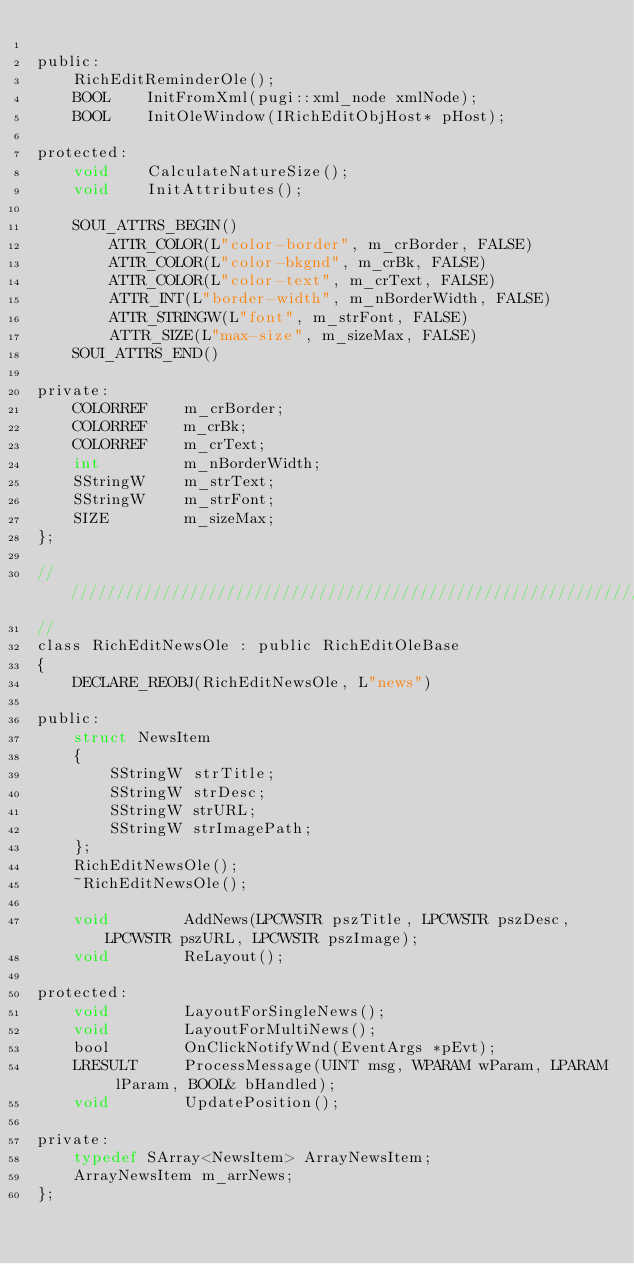Convert code to text. <code><loc_0><loc_0><loc_500><loc_500><_C_>
public:
    RichEditReminderOle();
    BOOL    InitFromXml(pugi::xml_node xmlNode);
    BOOL    InitOleWindow(IRichEditObjHost* pHost);

protected:
    void    CalculateNatureSize();
    void    InitAttributes();

    SOUI_ATTRS_BEGIN()
        ATTR_COLOR(L"color-border", m_crBorder, FALSE)
        ATTR_COLOR(L"color-bkgnd", m_crBk, FALSE)
        ATTR_COLOR(L"color-text", m_crText, FALSE)
        ATTR_INT(L"border-width", m_nBorderWidth, FALSE)
        ATTR_STRINGW(L"font", m_strFont, FALSE)
        ATTR_SIZE(L"max-size", m_sizeMax, FALSE)
    SOUI_ATTRS_END()

private:
    COLORREF    m_crBorder;
    COLORREF    m_crBk;
    COLORREF    m_crText;
    int         m_nBorderWidth;
    SStringW    m_strText;
    SStringW    m_strFont;
    SIZE        m_sizeMax;
};

//////////////////////////////////////////////////////////////////////////
//
class RichEditNewsOle : public RichEditOleBase
{    
    DECLARE_REOBJ(RichEditNewsOle, L"news")

public:
    struct NewsItem
    {
        SStringW strTitle;
        SStringW strDesc;
        SStringW strURL;
        SStringW strImagePath;
    };
    RichEditNewsOle();
    ~RichEditNewsOle();

    void        AddNews(LPCWSTR pszTitle, LPCWSTR pszDesc, LPCWSTR pszURL, LPCWSTR pszImage);
    void        ReLayout();

protected:
    void        LayoutForSingleNews();
    void        LayoutForMultiNews();
    bool        OnClickNotifyWnd(EventArgs *pEvt);
    LRESULT     ProcessMessage(UINT msg, WPARAM wParam, LPARAM lParam, BOOL& bHandled);
    void        UpdatePosition();

private:
    typedef SArray<NewsItem> ArrayNewsItem;
    ArrayNewsItem m_arrNews;
};
</code> 